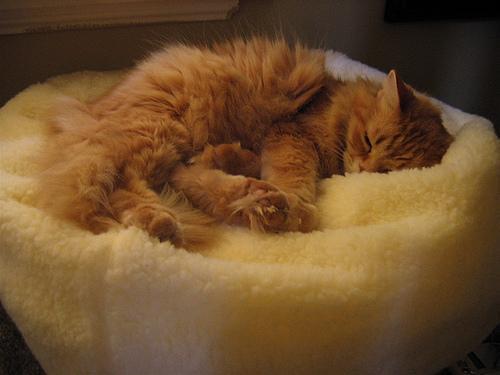How many cats are in the picture?
Give a very brief answer. 1. 